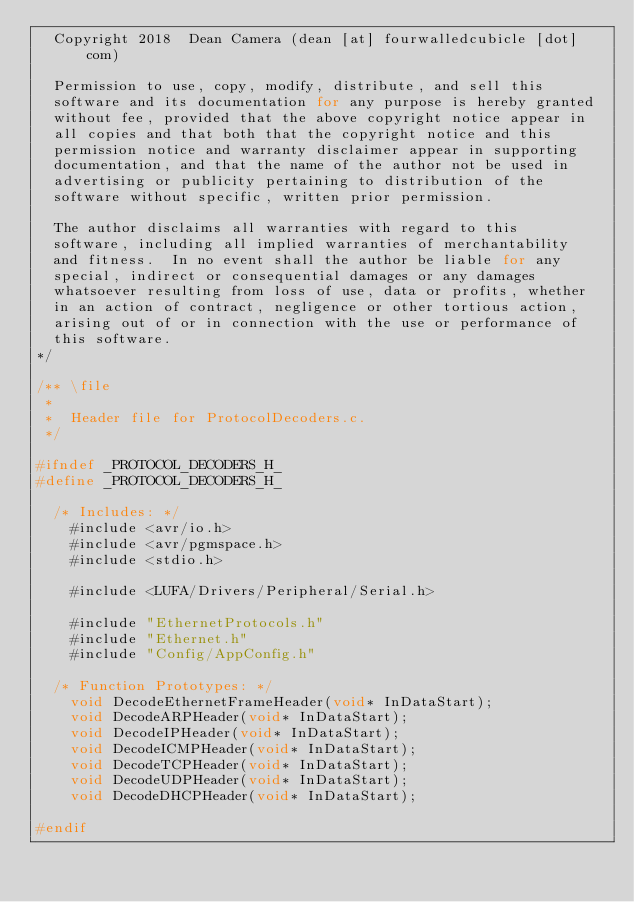Convert code to text. <code><loc_0><loc_0><loc_500><loc_500><_C_>  Copyright 2018  Dean Camera (dean [at] fourwalledcubicle [dot] com)

  Permission to use, copy, modify, distribute, and sell this
  software and its documentation for any purpose is hereby granted
  without fee, provided that the above copyright notice appear in
  all copies and that both that the copyright notice and this
  permission notice and warranty disclaimer appear in supporting
  documentation, and that the name of the author not be used in
  advertising or publicity pertaining to distribution of the
  software without specific, written prior permission.

  The author disclaims all warranties with regard to this
  software, including all implied warranties of merchantability
  and fitness.  In no event shall the author be liable for any
  special, indirect or consequential damages or any damages
  whatsoever resulting from loss of use, data or profits, whether
  in an action of contract, negligence or other tortious action,
  arising out of or in connection with the use or performance of
  this software.
*/

/** \file
 *
 *  Header file for ProtocolDecoders.c.
 */

#ifndef _PROTOCOL_DECODERS_H_
#define _PROTOCOL_DECODERS_H_

	/* Includes: */
		#include <avr/io.h>
		#include <avr/pgmspace.h>
		#include <stdio.h>

		#include <LUFA/Drivers/Peripheral/Serial.h>

		#include "EthernetProtocols.h"
		#include "Ethernet.h"
		#include "Config/AppConfig.h"

	/* Function Prototypes: */
		void DecodeEthernetFrameHeader(void* InDataStart);
		void DecodeARPHeader(void* InDataStart);
		void DecodeIPHeader(void* InDataStart);
		void DecodeICMPHeader(void* InDataStart);
		void DecodeTCPHeader(void* InDataStart);
		void DecodeUDPHeader(void* InDataStart);
		void DecodeDHCPHeader(void* InDataStart);

#endif

</code> 